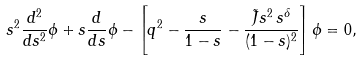Convert formula to latex. <formula><loc_0><loc_0><loc_500><loc_500>s ^ { 2 } \frac { d ^ { 2 } } { d s ^ { 2 } } \phi + s \frac { d } { d s } \phi - \left [ q ^ { 2 } - \frac { s } { 1 - s } - \frac { \tilde { J } s ^ { 2 } \, s ^ { \delta } } { ( 1 - s ) ^ { 2 } } \right ] \phi = 0 ,</formula> 